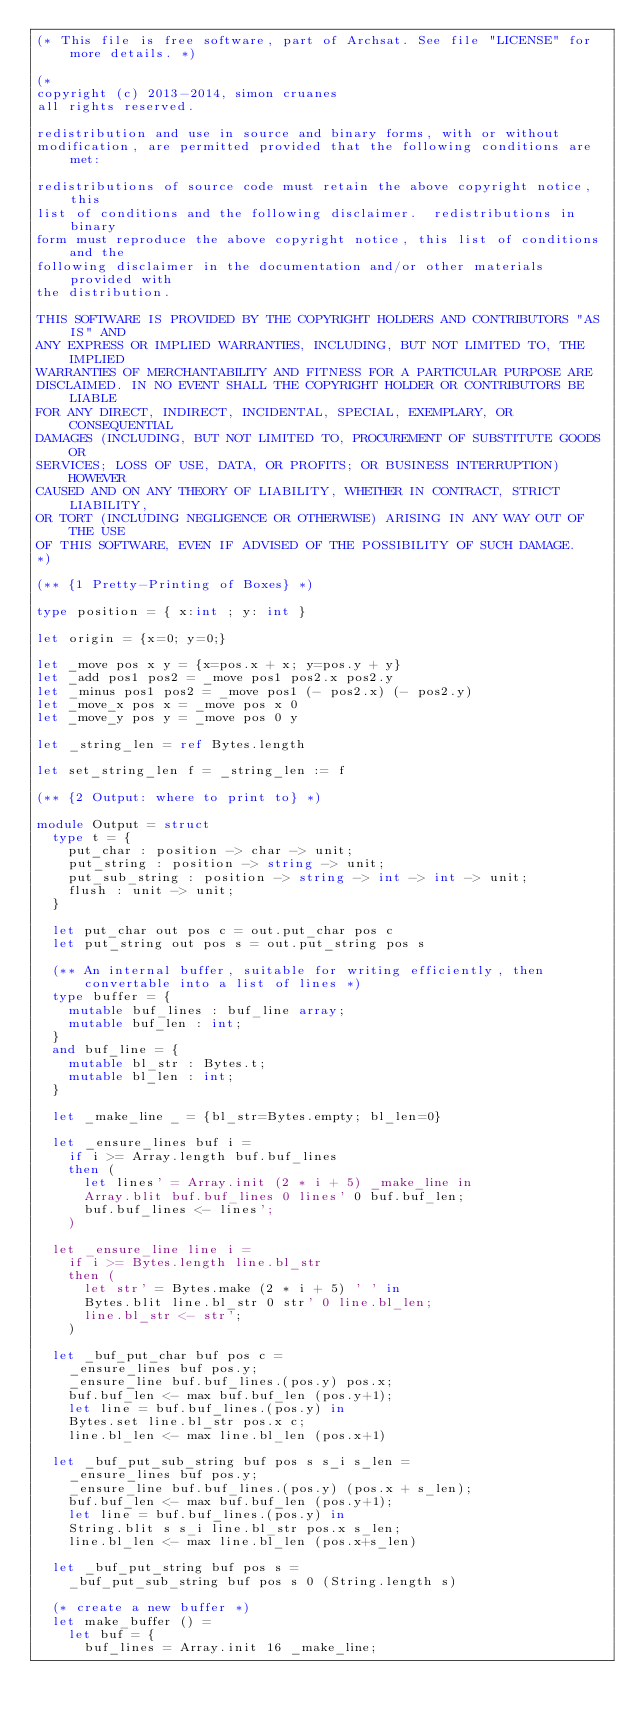<code> <loc_0><loc_0><loc_500><loc_500><_OCaml_>(* This file is free software, part of Archsat. See file "LICENSE" for more details. *)

(*
copyright (c) 2013-2014, simon cruanes
all rights reserved.

redistribution and use in source and binary forms, with or without
modification, are permitted provided that the following conditions are met:

redistributions of source code must retain the above copyright notice, this
list of conditions and the following disclaimer.  redistributions in binary
form must reproduce the above copyright notice, this list of conditions and the
following disclaimer in the documentation and/or other materials provided with
the distribution.

THIS SOFTWARE IS PROVIDED BY THE COPYRIGHT HOLDERS AND CONTRIBUTORS "AS IS" AND
ANY EXPRESS OR IMPLIED WARRANTIES, INCLUDING, BUT NOT LIMITED TO, THE IMPLIED
WARRANTIES OF MERCHANTABILITY AND FITNESS FOR A PARTICULAR PURPOSE ARE
DISCLAIMED. IN NO EVENT SHALL THE COPYRIGHT HOLDER OR CONTRIBUTORS BE LIABLE
FOR ANY DIRECT, INDIRECT, INCIDENTAL, SPECIAL, EXEMPLARY, OR CONSEQUENTIAL
DAMAGES (INCLUDING, BUT NOT LIMITED TO, PROCUREMENT OF SUBSTITUTE GOODS OR
SERVICES; LOSS OF USE, DATA, OR PROFITS; OR BUSINESS INTERRUPTION) HOWEVER
CAUSED AND ON ANY THEORY OF LIABILITY, WHETHER IN CONTRACT, STRICT LIABILITY,
OR TORT (INCLUDING NEGLIGENCE OR OTHERWISE) ARISING IN ANY WAY OUT OF THE USE
OF THIS SOFTWARE, EVEN IF ADVISED OF THE POSSIBILITY OF SUCH DAMAGE.
*)

(** {1 Pretty-Printing of Boxes} *)

type position = { x:int ; y: int }

let origin = {x=0; y=0;}

let _move pos x y = {x=pos.x + x; y=pos.y + y}
let _add pos1 pos2 = _move pos1 pos2.x pos2.y
let _minus pos1 pos2 = _move pos1 (- pos2.x) (- pos2.y)
let _move_x pos x = _move pos x 0
let _move_y pos y = _move pos 0 y

let _string_len = ref Bytes.length

let set_string_len f = _string_len := f

(** {2 Output: where to print to} *)

module Output = struct
  type t = {
    put_char : position -> char -> unit;
    put_string : position -> string -> unit;
    put_sub_string : position -> string -> int -> int -> unit;
    flush : unit -> unit;
  }

  let put_char out pos c = out.put_char pos c
  let put_string out pos s = out.put_string pos s

  (** An internal buffer, suitable for writing efficiently, then
      convertable into a list of lines *)
  type buffer = {
    mutable buf_lines : buf_line array;
    mutable buf_len : int;
  }
  and buf_line = {
    mutable bl_str : Bytes.t;
    mutable bl_len : int;
  }

  let _make_line _ = {bl_str=Bytes.empty; bl_len=0}

  let _ensure_lines buf i =
    if i >= Array.length buf.buf_lines
    then (
      let lines' = Array.init (2 * i + 5) _make_line in
      Array.blit buf.buf_lines 0 lines' 0 buf.buf_len;
      buf.buf_lines <- lines';
    )

  let _ensure_line line i =
    if i >= Bytes.length line.bl_str
    then (
      let str' = Bytes.make (2 * i + 5) ' ' in
      Bytes.blit line.bl_str 0 str' 0 line.bl_len;
      line.bl_str <- str';
    )

  let _buf_put_char buf pos c =
    _ensure_lines buf pos.y;
    _ensure_line buf.buf_lines.(pos.y) pos.x;
    buf.buf_len <- max buf.buf_len (pos.y+1);
    let line = buf.buf_lines.(pos.y) in
    Bytes.set line.bl_str pos.x c;
    line.bl_len <- max line.bl_len (pos.x+1)

  let _buf_put_sub_string buf pos s s_i s_len =
    _ensure_lines buf pos.y;
    _ensure_line buf.buf_lines.(pos.y) (pos.x + s_len);
    buf.buf_len <- max buf.buf_len (pos.y+1);
    let line = buf.buf_lines.(pos.y) in
    String.blit s s_i line.bl_str pos.x s_len;
    line.bl_len <- max line.bl_len (pos.x+s_len)

  let _buf_put_string buf pos s =
    _buf_put_sub_string buf pos s 0 (String.length s)

  (* create a new buffer *)
  let make_buffer () =
    let buf = {
      buf_lines = Array.init 16 _make_line;</code> 